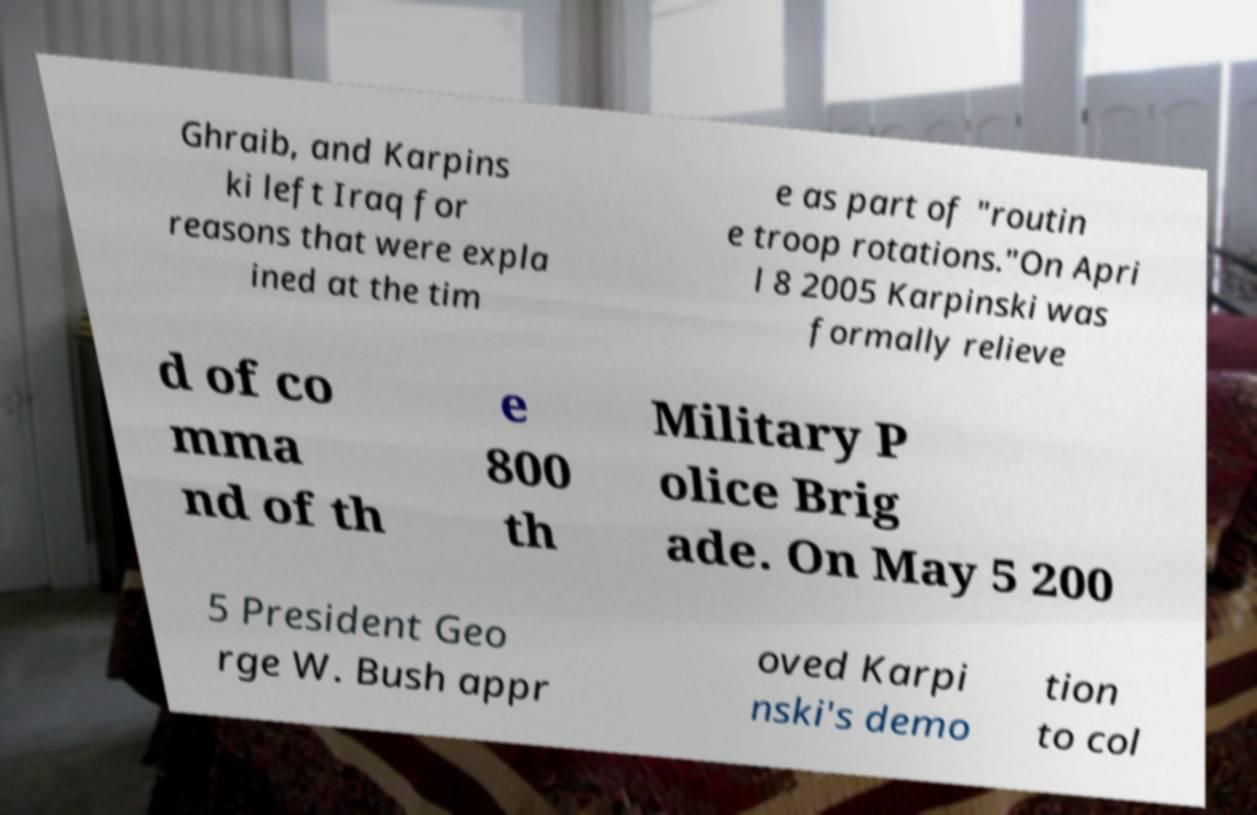Could you extract and type out the text from this image? Ghraib, and Karpins ki left Iraq for reasons that were expla ined at the tim e as part of "routin e troop rotations."On Apri l 8 2005 Karpinski was formally relieve d of co mma nd of th e 800 th Military P olice Brig ade. On May 5 200 5 President Geo rge W. Bush appr oved Karpi nski's demo tion to col 